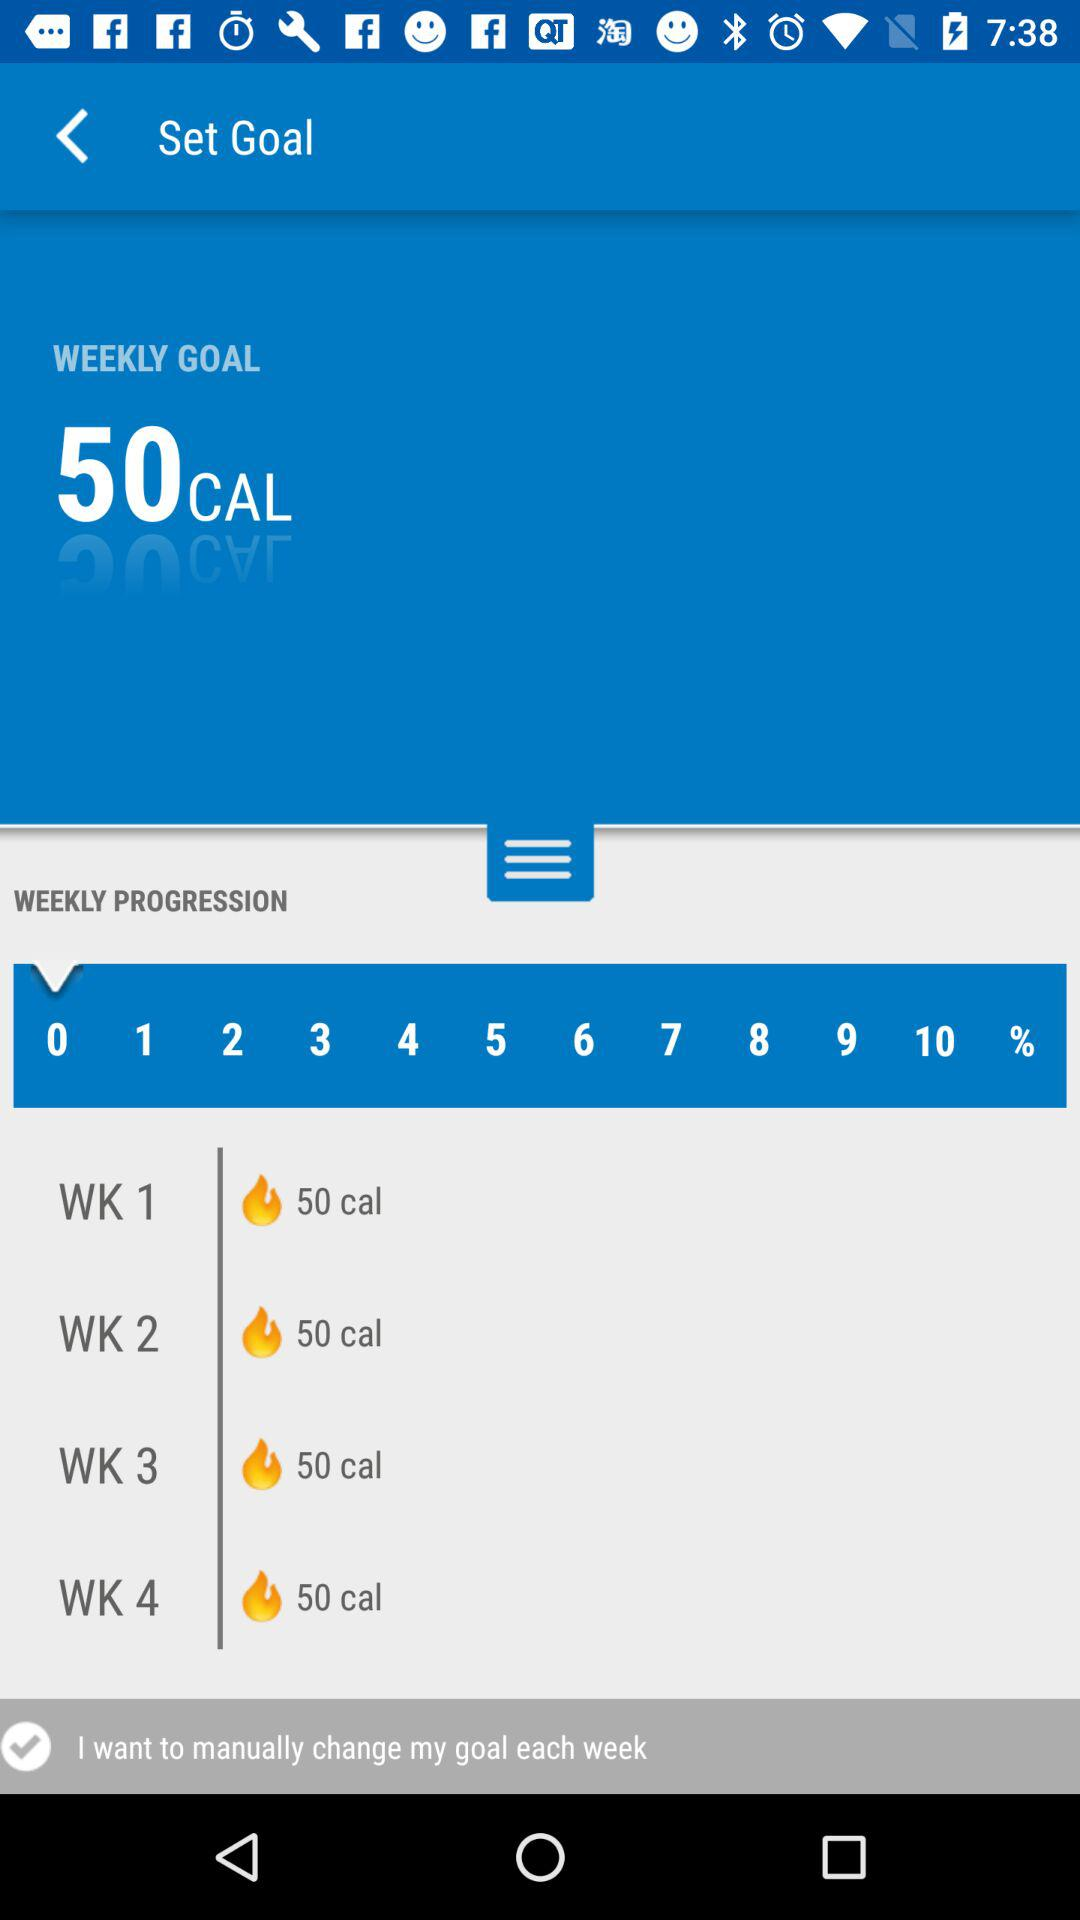What is the weekly goal? The weekly goal is "50CAL". 